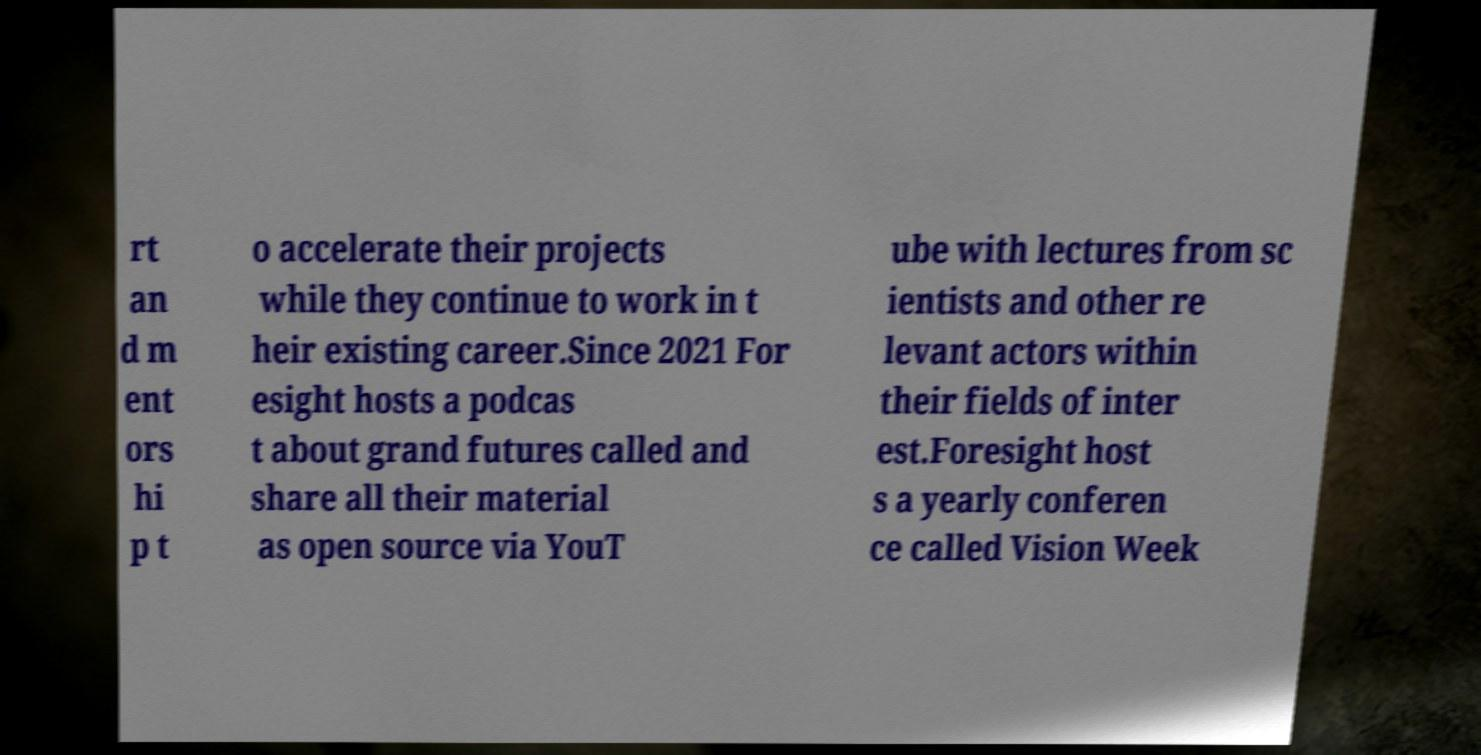Can you read and provide the text displayed in the image?This photo seems to have some interesting text. Can you extract and type it out for me? rt an d m ent ors hi p t o accelerate their projects while they continue to work in t heir existing career.Since 2021 For esight hosts a podcas t about grand futures called and share all their material as open source via YouT ube with lectures from sc ientists and other re levant actors within their fields of inter est.Foresight host s a yearly conferen ce called Vision Week 